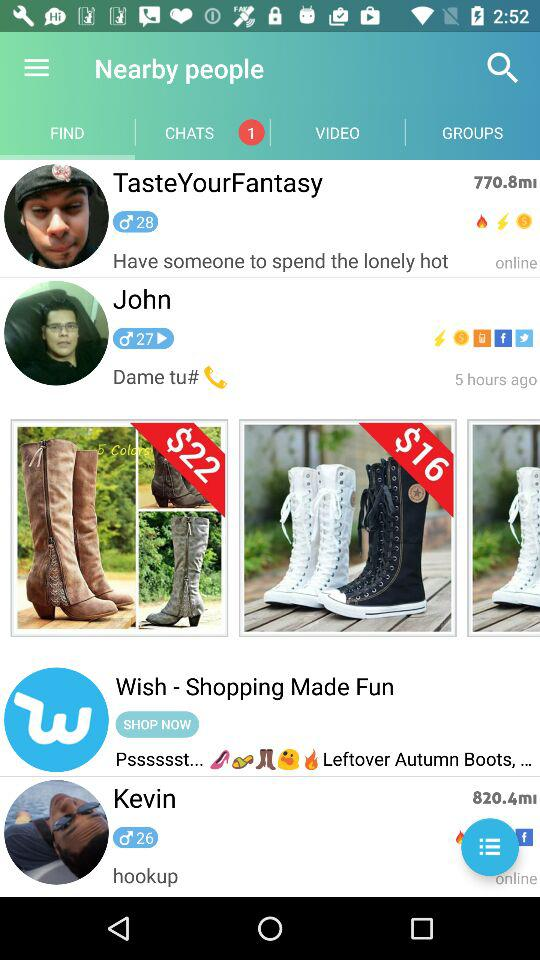What's the age of John? The age of John is 27. 